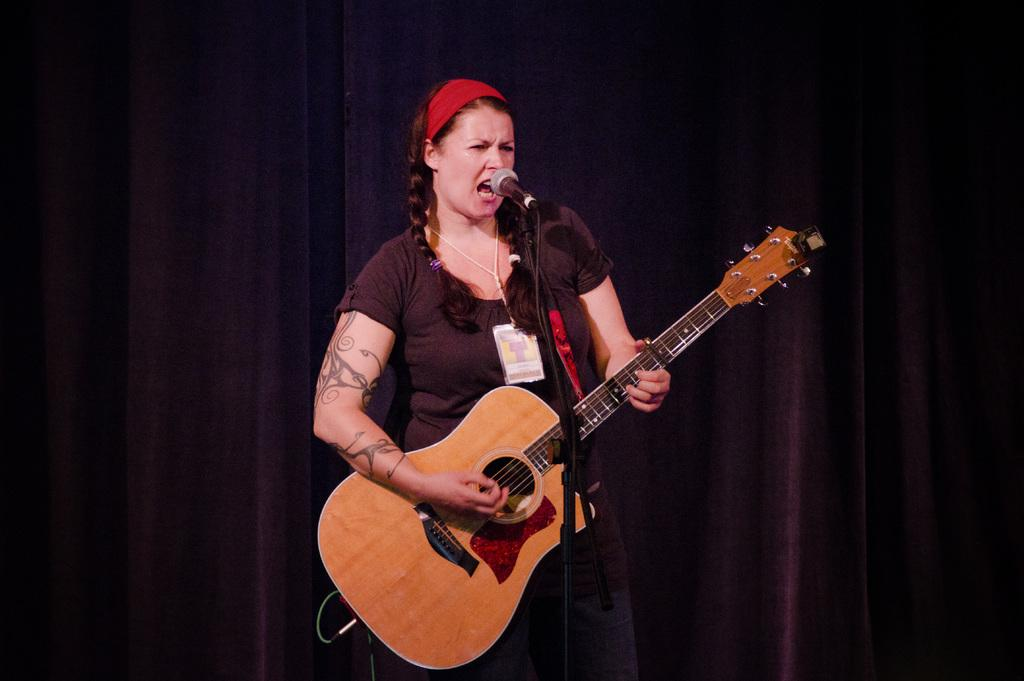Who is the main subject in the image? There is a woman in the image. What is the woman doing in the image? The woman is standing, playing a guitar, and singing into a microphone. What can be seen in the background of the image? There is a curtain in the background of the image. What type of belief is the woman expressing through her cow in the image? There is no cow present in the image, and therefore no belief can be expressed through it. 